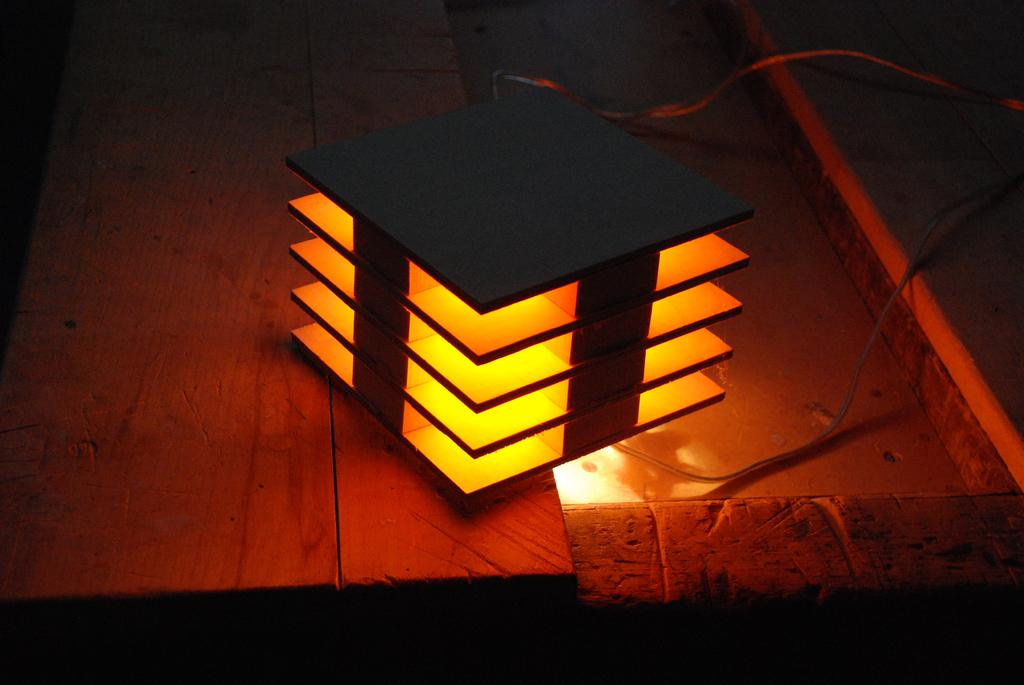What is the main subject in the center of the image? There is an object in the center of the image. What is the color of the light inside the object? The object has an orange colored light inside it. What else can be seen in the image besides the object? There are wires visible in the image. What type of surface is present in the image? There is a wooden surface in the image. How does the feather increase the brightness of the orange light in the image? There is no feather present in the image, so it cannot increase the brightness of the orange light. 